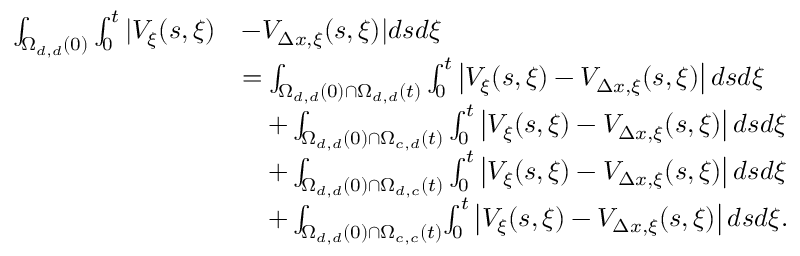Convert formula to latex. <formula><loc_0><loc_0><loc_500><loc_500>\begin{array} { r l } { \int _ { \Omega _ { d , d } ( 0 ) } \int _ { 0 } ^ { t } | V _ { \xi } ( s , \xi ) } & { - V _ { \Delta x , \xi } ( s , \xi ) | d s d \xi } \\ & { = \int _ { \Omega _ { d , d } ( 0 ) \cap \Omega _ { d , d } ( t ) } \int _ { 0 } ^ { t } \left | V _ { \xi } ( s , \xi ) - V _ { \Delta x , \xi } ( s , \xi ) \right | d s d \xi } \\ & { \quad + \int _ { \Omega _ { d , d } ( 0 ) \cap \Omega _ { c , d } ( t ) } \int _ { 0 } ^ { t } \left | V _ { \xi } ( s , \xi ) - V _ { \Delta x , \xi } ( s , \xi ) \right | d s d \xi } \\ & { \quad + \int _ { \Omega _ { d , d } ( 0 ) \cap \Omega _ { d , c } ( t ) } \int _ { 0 } ^ { t } \left | V _ { \xi } ( s , \xi ) - V _ { \Delta x , \xi } ( s , \xi ) \right | d s d \xi } \\ & { \quad + \int _ { \Omega _ { d , d } ( 0 ) \cap \Omega _ { c , c } ( t ) } \, \int _ { 0 } ^ { t } \left | V _ { \xi } ( s , \xi ) - V _ { \Delta x , \xi } ( s , \xi ) \right | d s d \xi . } \end{array}</formula> 